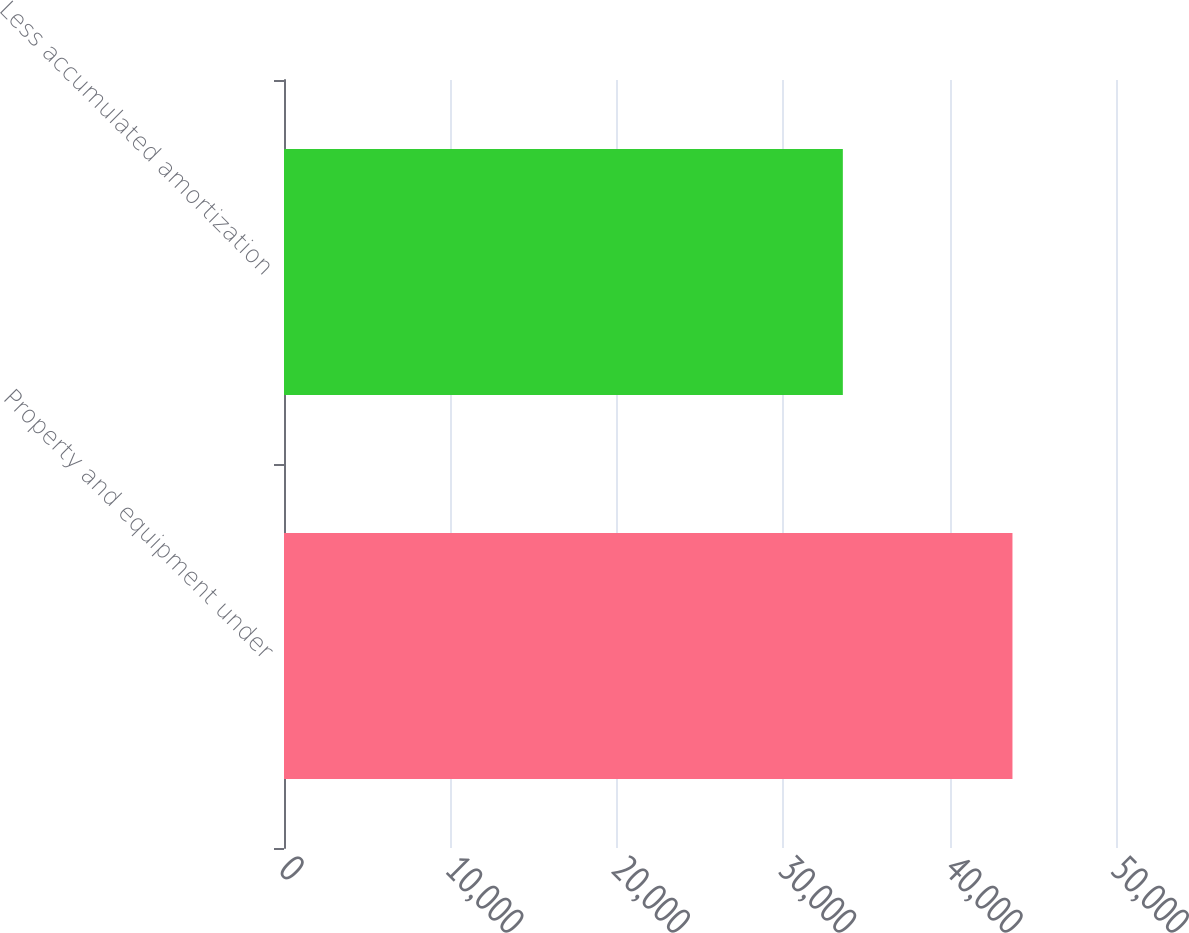<chart> <loc_0><loc_0><loc_500><loc_500><bar_chart><fcel>Property and equipment under<fcel>Less accumulated amortization<nl><fcel>43778<fcel>33584<nl></chart> 